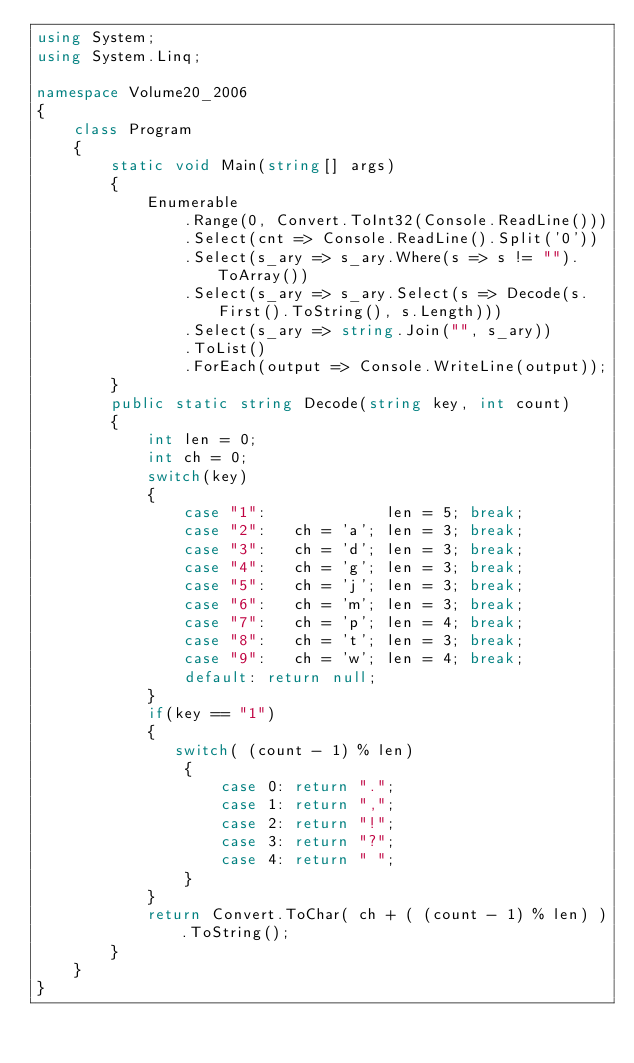<code> <loc_0><loc_0><loc_500><loc_500><_C#_>using System;
using System.Linq;

namespace Volume20_2006
{
    class Program
    {
        static void Main(string[] args)
        {
            Enumerable
                .Range(0, Convert.ToInt32(Console.ReadLine()))
                .Select(cnt => Console.ReadLine().Split('0'))
                .Select(s_ary => s_ary.Where(s => s != "").ToArray())
                .Select(s_ary => s_ary.Select(s => Decode(s.First().ToString(), s.Length)))
                .Select(s_ary => string.Join("", s_ary))
                .ToList()
                .ForEach(output => Console.WriteLine(output));
        }
        public static string Decode(string key, int count)
        {
            int len = 0;
            int ch = 0;
            switch(key)
            {
                case "1":             len = 5; break;
                case "2":   ch = 'a'; len = 3; break;
                case "3":   ch = 'd'; len = 3; break;
                case "4":   ch = 'g'; len = 3; break;
                case "5":   ch = 'j'; len = 3; break;
                case "6":   ch = 'm'; len = 3; break;
                case "7":   ch = 'p'; len = 4; break;
                case "8":   ch = 't'; len = 3; break;
                case "9":   ch = 'w'; len = 4; break;
                default: return null;
            }
            if(key == "1")
            {
               switch( (count - 1) % len)
                {
                    case 0: return ".";
                    case 1: return ",";
                    case 2: return "!";
                    case 3: return "?";
                    case 4: return " ";
                }
            }
            return Convert.ToChar( ch + ( (count - 1) % len) ).ToString();
        }
    }
}</code> 